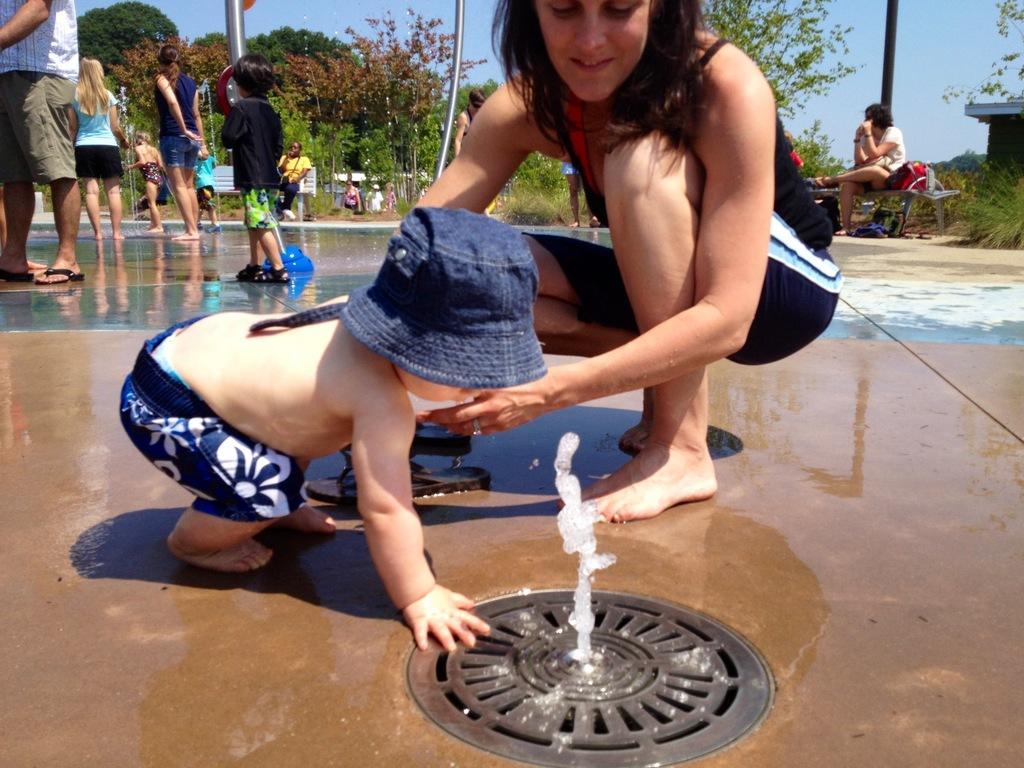Could you give a brief overview of what you see in this image? In the background we can see the sky, trees, plants. We can see the people sitting on the benches. In this picture we can see the people standing on the wet floor. We can see the poles. This picture is mainly highlighted with a woman and a baby wearing a cap. We can see water and an object 